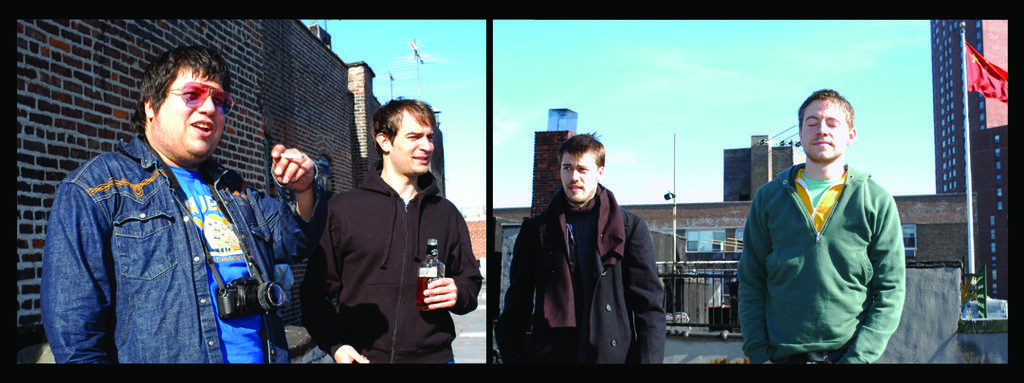Could you give a brief overview of what you see in this image? Collage picture. In this picture we can see people. This person is holding a bottle. This person worn camera. Background there are buildings. Sky is in blue color. Right side of the image we can see flag. Sky is in blue color. 